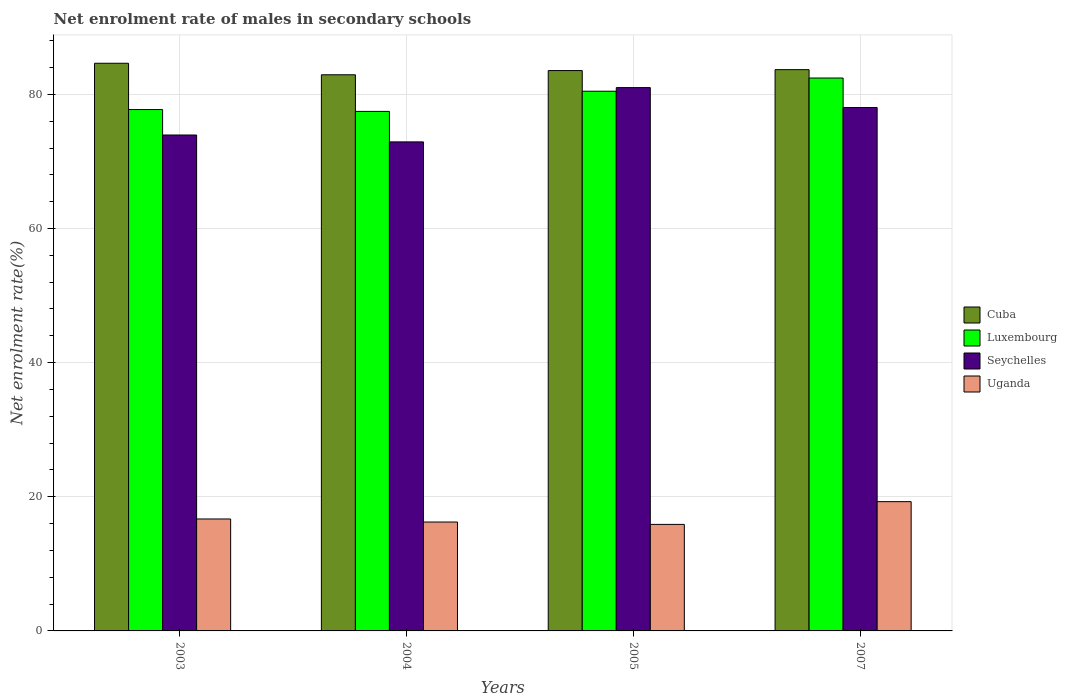How many different coloured bars are there?
Keep it short and to the point. 4. How many groups of bars are there?
Provide a succinct answer. 4. Are the number of bars on each tick of the X-axis equal?
Keep it short and to the point. Yes. What is the label of the 2nd group of bars from the left?
Your answer should be compact. 2004. What is the net enrolment rate of males in secondary schools in Luxembourg in 2005?
Your answer should be very brief. 80.46. Across all years, what is the maximum net enrolment rate of males in secondary schools in Cuba?
Your answer should be very brief. 84.63. Across all years, what is the minimum net enrolment rate of males in secondary schools in Seychelles?
Your answer should be compact. 72.91. What is the total net enrolment rate of males in secondary schools in Luxembourg in the graph?
Your answer should be compact. 318.09. What is the difference between the net enrolment rate of males in secondary schools in Cuba in 2004 and that in 2007?
Your answer should be very brief. -0.76. What is the difference between the net enrolment rate of males in secondary schools in Cuba in 2003 and the net enrolment rate of males in secondary schools in Uganda in 2004?
Keep it short and to the point. 68.4. What is the average net enrolment rate of males in secondary schools in Luxembourg per year?
Offer a very short reply. 79.52. In the year 2003, what is the difference between the net enrolment rate of males in secondary schools in Luxembourg and net enrolment rate of males in secondary schools in Seychelles?
Offer a terse response. 3.8. What is the ratio of the net enrolment rate of males in secondary schools in Seychelles in 2004 to that in 2007?
Your answer should be compact. 0.93. What is the difference between the highest and the second highest net enrolment rate of males in secondary schools in Seychelles?
Your answer should be very brief. 2.97. What is the difference between the highest and the lowest net enrolment rate of males in secondary schools in Cuba?
Ensure brevity in your answer.  1.72. What does the 4th bar from the left in 2004 represents?
Offer a terse response. Uganda. What does the 1st bar from the right in 2004 represents?
Provide a succinct answer. Uganda. Is it the case that in every year, the sum of the net enrolment rate of males in secondary schools in Uganda and net enrolment rate of males in secondary schools in Cuba is greater than the net enrolment rate of males in secondary schools in Luxembourg?
Give a very brief answer. Yes. Are all the bars in the graph horizontal?
Give a very brief answer. No. How many years are there in the graph?
Ensure brevity in your answer.  4. What is the difference between two consecutive major ticks on the Y-axis?
Give a very brief answer. 20. How many legend labels are there?
Provide a succinct answer. 4. How are the legend labels stacked?
Give a very brief answer. Vertical. What is the title of the graph?
Ensure brevity in your answer.  Net enrolment rate of males in secondary schools. What is the label or title of the Y-axis?
Make the answer very short. Net enrolment rate(%). What is the Net enrolment rate(%) in Cuba in 2003?
Ensure brevity in your answer.  84.63. What is the Net enrolment rate(%) of Luxembourg in 2003?
Your response must be concise. 77.73. What is the Net enrolment rate(%) in Seychelles in 2003?
Provide a short and direct response. 73.94. What is the Net enrolment rate(%) of Uganda in 2003?
Provide a succinct answer. 16.69. What is the Net enrolment rate(%) of Cuba in 2004?
Give a very brief answer. 82.92. What is the Net enrolment rate(%) in Luxembourg in 2004?
Ensure brevity in your answer.  77.46. What is the Net enrolment rate(%) of Seychelles in 2004?
Provide a succinct answer. 72.91. What is the Net enrolment rate(%) in Uganda in 2004?
Offer a terse response. 16.24. What is the Net enrolment rate(%) of Cuba in 2005?
Ensure brevity in your answer.  83.54. What is the Net enrolment rate(%) of Luxembourg in 2005?
Your answer should be very brief. 80.46. What is the Net enrolment rate(%) in Seychelles in 2005?
Provide a short and direct response. 81. What is the Net enrolment rate(%) of Uganda in 2005?
Offer a very short reply. 15.88. What is the Net enrolment rate(%) in Cuba in 2007?
Provide a succinct answer. 83.68. What is the Net enrolment rate(%) of Luxembourg in 2007?
Give a very brief answer. 82.43. What is the Net enrolment rate(%) of Seychelles in 2007?
Offer a terse response. 78.04. What is the Net enrolment rate(%) in Uganda in 2007?
Your answer should be compact. 19.27. Across all years, what is the maximum Net enrolment rate(%) of Cuba?
Offer a terse response. 84.63. Across all years, what is the maximum Net enrolment rate(%) in Luxembourg?
Your response must be concise. 82.43. Across all years, what is the maximum Net enrolment rate(%) of Seychelles?
Your answer should be very brief. 81. Across all years, what is the maximum Net enrolment rate(%) in Uganda?
Your response must be concise. 19.27. Across all years, what is the minimum Net enrolment rate(%) of Cuba?
Your answer should be very brief. 82.92. Across all years, what is the minimum Net enrolment rate(%) of Luxembourg?
Offer a terse response. 77.46. Across all years, what is the minimum Net enrolment rate(%) of Seychelles?
Give a very brief answer. 72.91. Across all years, what is the minimum Net enrolment rate(%) in Uganda?
Your response must be concise. 15.88. What is the total Net enrolment rate(%) in Cuba in the graph?
Make the answer very short. 334.78. What is the total Net enrolment rate(%) in Luxembourg in the graph?
Offer a terse response. 318.09. What is the total Net enrolment rate(%) of Seychelles in the graph?
Make the answer very short. 305.89. What is the total Net enrolment rate(%) of Uganda in the graph?
Make the answer very short. 68.08. What is the difference between the Net enrolment rate(%) in Cuba in 2003 and that in 2004?
Provide a succinct answer. 1.72. What is the difference between the Net enrolment rate(%) of Luxembourg in 2003 and that in 2004?
Offer a terse response. 0.28. What is the difference between the Net enrolment rate(%) of Seychelles in 2003 and that in 2004?
Give a very brief answer. 1.03. What is the difference between the Net enrolment rate(%) of Uganda in 2003 and that in 2004?
Make the answer very short. 0.45. What is the difference between the Net enrolment rate(%) of Cuba in 2003 and that in 2005?
Offer a terse response. 1.09. What is the difference between the Net enrolment rate(%) of Luxembourg in 2003 and that in 2005?
Your answer should be compact. -2.73. What is the difference between the Net enrolment rate(%) of Seychelles in 2003 and that in 2005?
Offer a very short reply. -7.07. What is the difference between the Net enrolment rate(%) of Uganda in 2003 and that in 2005?
Make the answer very short. 0.81. What is the difference between the Net enrolment rate(%) of Cuba in 2003 and that in 2007?
Ensure brevity in your answer.  0.95. What is the difference between the Net enrolment rate(%) in Luxembourg in 2003 and that in 2007?
Your response must be concise. -4.7. What is the difference between the Net enrolment rate(%) in Seychelles in 2003 and that in 2007?
Your answer should be compact. -4.1. What is the difference between the Net enrolment rate(%) in Uganda in 2003 and that in 2007?
Keep it short and to the point. -2.58. What is the difference between the Net enrolment rate(%) in Cuba in 2004 and that in 2005?
Provide a short and direct response. -0.63. What is the difference between the Net enrolment rate(%) in Luxembourg in 2004 and that in 2005?
Ensure brevity in your answer.  -3.01. What is the difference between the Net enrolment rate(%) in Seychelles in 2004 and that in 2005?
Keep it short and to the point. -8.09. What is the difference between the Net enrolment rate(%) in Uganda in 2004 and that in 2005?
Provide a short and direct response. 0.36. What is the difference between the Net enrolment rate(%) of Cuba in 2004 and that in 2007?
Ensure brevity in your answer.  -0.76. What is the difference between the Net enrolment rate(%) of Luxembourg in 2004 and that in 2007?
Ensure brevity in your answer.  -4.97. What is the difference between the Net enrolment rate(%) of Seychelles in 2004 and that in 2007?
Your answer should be compact. -5.13. What is the difference between the Net enrolment rate(%) in Uganda in 2004 and that in 2007?
Provide a succinct answer. -3.04. What is the difference between the Net enrolment rate(%) of Cuba in 2005 and that in 2007?
Provide a short and direct response. -0.14. What is the difference between the Net enrolment rate(%) of Luxembourg in 2005 and that in 2007?
Offer a terse response. -1.97. What is the difference between the Net enrolment rate(%) of Seychelles in 2005 and that in 2007?
Offer a terse response. 2.97. What is the difference between the Net enrolment rate(%) in Uganda in 2005 and that in 2007?
Offer a very short reply. -3.39. What is the difference between the Net enrolment rate(%) of Cuba in 2003 and the Net enrolment rate(%) of Luxembourg in 2004?
Your answer should be very brief. 7.18. What is the difference between the Net enrolment rate(%) of Cuba in 2003 and the Net enrolment rate(%) of Seychelles in 2004?
Your response must be concise. 11.72. What is the difference between the Net enrolment rate(%) in Cuba in 2003 and the Net enrolment rate(%) in Uganda in 2004?
Make the answer very short. 68.4. What is the difference between the Net enrolment rate(%) of Luxembourg in 2003 and the Net enrolment rate(%) of Seychelles in 2004?
Offer a terse response. 4.82. What is the difference between the Net enrolment rate(%) of Luxembourg in 2003 and the Net enrolment rate(%) of Uganda in 2004?
Your answer should be very brief. 61.5. What is the difference between the Net enrolment rate(%) in Seychelles in 2003 and the Net enrolment rate(%) in Uganda in 2004?
Make the answer very short. 57.7. What is the difference between the Net enrolment rate(%) in Cuba in 2003 and the Net enrolment rate(%) in Luxembourg in 2005?
Provide a short and direct response. 4.17. What is the difference between the Net enrolment rate(%) in Cuba in 2003 and the Net enrolment rate(%) in Seychelles in 2005?
Offer a very short reply. 3.63. What is the difference between the Net enrolment rate(%) in Cuba in 2003 and the Net enrolment rate(%) in Uganda in 2005?
Give a very brief answer. 68.75. What is the difference between the Net enrolment rate(%) of Luxembourg in 2003 and the Net enrolment rate(%) of Seychelles in 2005?
Provide a short and direct response. -3.27. What is the difference between the Net enrolment rate(%) in Luxembourg in 2003 and the Net enrolment rate(%) in Uganda in 2005?
Make the answer very short. 61.85. What is the difference between the Net enrolment rate(%) in Seychelles in 2003 and the Net enrolment rate(%) in Uganda in 2005?
Ensure brevity in your answer.  58.06. What is the difference between the Net enrolment rate(%) in Cuba in 2003 and the Net enrolment rate(%) in Luxembourg in 2007?
Give a very brief answer. 2.2. What is the difference between the Net enrolment rate(%) of Cuba in 2003 and the Net enrolment rate(%) of Seychelles in 2007?
Keep it short and to the point. 6.6. What is the difference between the Net enrolment rate(%) in Cuba in 2003 and the Net enrolment rate(%) in Uganda in 2007?
Provide a succinct answer. 65.36. What is the difference between the Net enrolment rate(%) of Luxembourg in 2003 and the Net enrolment rate(%) of Seychelles in 2007?
Make the answer very short. -0.3. What is the difference between the Net enrolment rate(%) of Luxembourg in 2003 and the Net enrolment rate(%) of Uganda in 2007?
Offer a terse response. 58.46. What is the difference between the Net enrolment rate(%) of Seychelles in 2003 and the Net enrolment rate(%) of Uganda in 2007?
Make the answer very short. 54.66. What is the difference between the Net enrolment rate(%) in Cuba in 2004 and the Net enrolment rate(%) in Luxembourg in 2005?
Your response must be concise. 2.45. What is the difference between the Net enrolment rate(%) of Cuba in 2004 and the Net enrolment rate(%) of Seychelles in 2005?
Ensure brevity in your answer.  1.91. What is the difference between the Net enrolment rate(%) of Cuba in 2004 and the Net enrolment rate(%) of Uganda in 2005?
Your answer should be very brief. 67.04. What is the difference between the Net enrolment rate(%) in Luxembourg in 2004 and the Net enrolment rate(%) in Seychelles in 2005?
Provide a short and direct response. -3.55. What is the difference between the Net enrolment rate(%) in Luxembourg in 2004 and the Net enrolment rate(%) in Uganda in 2005?
Offer a terse response. 61.58. What is the difference between the Net enrolment rate(%) in Seychelles in 2004 and the Net enrolment rate(%) in Uganda in 2005?
Give a very brief answer. 57.03. What is the difference between the Net enrolment rate(%) of Cuba in 2004 and the Net enrolment rate(%) of Luxembourg in 2007?
Provide a short and direct response. 0.49. What is the difference between the Net enrolment rate(%) of Cuba in 2004 and the Net enrolment rate(%) of Seychelles in 2007?
Provide a short and direct response. 4.88. What is the difference between the Net enrolment rate(%) of Cuba in 2004 and the Net enrolment rate(%) of Uganda in 2007?
Keep it short and to the point. 63.64. What is the difference between the Net enrolment rate(%) in Luxembourg in 2004 and the Net enrolment rate(%) in Seychelles in 2007?
Ensure brevity in your answer.  -0.58. What is the difference between the Net enrolment rate(%) in Luxembourg in 2004 and the Net enrolment rate(%) in Uganda in 2007?
Your answer should be very brief. 58.19. What is the difference between the Net enrolment rate(%) in Seychelles in 2004 and the Net enrolment rate(%) in Uganda in 2007?
Offer a very short reply. 53.64. What is the difference between the Net enrolment rate(%) of Cuba in 2005 and the Net enrolment rate(%) of Luxembourg in 2007?
Provide a short and direct response. 1.11. What is the difference between the Net enrolment rate(%) of Cuba in 2005 and the Net enrolment rate(%) of Seychelles in 2007?
Provide a short and direct response. 5.51. What is the difference between the Net enrolment rate(%) of Cuba in 2005 and the Net enrolment rate(%) of Uganda in 2007?
Provide a succinct answer. 64.27. What is the difference between the Net enrolment rate(%) of Luxembourg in 2005 and the Net enrolment rate(%) of Seychelles in 2007?
Provide a short and direct response. 2.43. What is the difference between the Net enrolment rate(%) in Luxembourg in 2005 and the Net enrolment rate(%) in Uganda in 2007?
Give a very brief answer. 61.19. What is the difference between the Net enrolment rate(%) of Seychelles in 2005 and the Net enrolment rate(%) of Uganda in 2007?
Ensure brevity in your answer.  61.73. What is the average Net enrolment rate(%) of Cuba per year?
Make the answer very short. 83.69. What is the average Net enrolment rate(%) in Luxembourg per year?
Your answer should be compact. 79.52. What is the average Net enrolment rate(%) of Seychelles per year?
Offer a very short reply. 76.47. What is the average Net enrolment rate(%) of Uganda per year?
Make the answer very short. 17.02. In the year 2003, what is the difference between the Net enrolment rate(%) of Cuba and Net enrolment rate(%) of Luxembourg?
Offer a terse response. 6.9. In the year 2003, what is the difference between the Net enrolment rate(%) of Cuba and Net enrolment rate(%) of Seychelles?
Ensure brevity in your answer.  10.7. In the year 2003, what is the difference between the Net enrolment rate(%) of Cuba and Net enrolment rate(%) of Uganda?
Ensure brevity in your answer.  67.94. In the year 2003, what is the difference between the Net enrolment rate(%) of Luxembourg and Net enrolment rate(%) of Seychelles?
Provide a short and direct response. 3.8. In the year 2003, what is the difference between the Net enrolment rate(%) of Luxembourg and Net enrolment rate(%) of Uganda?
Keep it short and to the point. 61.04. In the year 2003, what is the difference between the Net enrolment rate(%) in Seychelles and Net enrolment rate(%) in Uganda?
Your answer should be compact. 57.25. In the year 2004, what is the difference between the Net enrolment rate(%) of Cuba and Net enrolment rate(%) of Luxembourg?
Provide a succinct answer. 5.46. In the year 2004, what is the difference between the Net enrolment rate(%) of Cuba and Net enrolment rate(%) of Seychelles?
Your response must be concise. 10.01. In the year 2004, what is the difference between the Net enrolment rate(%) of Cuba and Net enrolment rate(%) of Uganda?
Keep it short and to the point. 66.68. In the year 2004, what is the difference between the Net enrolment rate(%) of Luxembourg and Net enrolment rate(%) of Seychelles?
Make the answer very short. 4.55. In the year 2004, what is the difference between the Net enrolment rate(%) in Luxembourg and Net enrolment rate(%) in Uganda?
Your answer should be very brief. 61.22. In the year 2004, what is the difference between the Net enrolment rate(%) in Seychelles and Net enrolment rate(%) in Uganda?
Give a very brief answer. 56.67. In the year 2005, what is the difference between the Net enrolment rate(%) in Cuba and Net enrolment rate(%) in Luxembourg?
Offer a terse response. 3.08. In the year 2005, what is the difference between the Net enrolment rate(%) in Cuba and Net enrolment rate(%) in Seychelles?
Make the answer very short. 2.54. In the year 2005, what is the difference between the Net enrolment rate(%) in Cuba and Net enrolment rate(%) in Uganda?
Your response must be concise. 67.66. In the year 2005, what is the difference between the Net enrolment rate(%) in Luxembourg and Net enrolment rate(%) in Seychelles?
Offer a terse response. -0.54. In the year 2005, what is the difference between the Net enrolment rate(%) of Luxembourg and Net enrolment rate(%) of Uganda?
Keep it short and to the point. 64.58. In the year 2005, what is the difference between the Net enrolment rate(%) of Seychelles and Net enrolment rate(%) of Uganda?
Keep it short and to the point. 65.12. In the year 2007, what is the difference between the Net enrolment rate(%) in Cuba and Net enrolment rate(%) in Luxembourg?
Provide a succinct answer. 1.25. In the year 2007, what is the difference between the Net enrolment rate(%) of Cuba and Net enrolment rate(%) of Seychelles?
Make the answer very short. 5.64. In the year 2007, what is the difference between the Net enrolment rate(%) of Cuba and Net enrolment rate(%) of Uganda?
Ensure brevity in your answer.  64.41. In the year 2007, what is the difference between the Net enrolment rate(%) in Luxembourg and Net enrolment rate(%) in Seychelles?
Your answer should be compact. 4.4. In the year 2007, what is the difference between the Net enrolment rate(%) of Luxembourg and Net enrolment rate(%) of Uganda?
Make the answer very short. 63.16. In the year 2007, what is the difference between the Net enrolment rate(%) in Seychelles and Net enrolment rate(%) in Uganda?
Your answer should be very brief. 58.76. What is the ratio of the Net enrolment rate(%) in Cuba in 2003 to that in 2004?
Your answer should be very brief. 1.02. What is the ratio of the Net enrolment rate(%) in Luxembourg in 2003 to that in 2004?
Make the answer very short. 1. What is the ratio of the Net enrolment rate(%) of Seychelles in 2003 to that in 2004?
Your answer should be very brief. 1.01. What is the ratio of the Net enrolment rate(%) of Uganda in 2003 to that in 2004?
Give a very brief answer. 1.03. What is the ratio of the Net enrolment rate(%) of Luxembourg in 2003 to that in 2005?
Your response must be concise. 0.97. What is the ratio of the Net enrolment rate(%) in Seychelles in 2003 to that in 2005?
Your answer should be very brief. 0.91. What is the ratio of the Net enrolment rate(%) in Uganda in 2003 to that in 2005?
Provide a short and direct response. 1.05. What is the ratio of the Net enrolment rate(%) of Cuba in 2003 to that in 2007?
Your answer should be compact. 1.01. What is the ratio of the Net enrolment rate(%) in Luxembourg in 2003 to that in 2007?
Ensure brevity in your answer.  0.94. What is the ratio of the Net enrolment rate(%) of Seychelles in 2003 to that in 2007?
Your answer should be very brief. 0.95. What is the ratio of the Net enrolment rate(%) of Uganda in 2003 to that in 2007?
Ensure brevity in your answer.  0.87. What is the ratio of the Net enrolment rate(%) of Luxembourg in 2004 to that in 2005?
Provide a succinct answer. 0.96. What is the ratio of the Net enrolment rate(%) of Seychelles in 2004 to that in 2005?
Make the answer very short. 0.9. What is the ratio of the Net enrolment rate(%) of Uganda in 2004 to that in 2005?
Offer a very short reply. 1.02. What is the ratio of the Net enrolment rate(%) in Cuba in 2004 to that in 2007?
Your response must be concise. 0.99. What is the ratio of the Net enrolment rate(%) of Luxembourg in 2004 to that in 2007?
Provide a succinct answer. 0.94. What is the ratio of the Net enrolment rate(%) in Seychelles in 2004 to that in 2007?
Give a very brief answer. 0.93. What is the ratio of the Net enrolment rate(%) of Uganda in 2004 to that in 2007?
Keep it short and to the point. 0.84. What is the ratio of the Net enrolment rate(%) in Cuba in 2005 to that in 2007?
Ensure brevity in your answer.  1. What is the ratio of the Net enrolment rate(%) of Luxembourg in 2005 to that in 2007?
Make the answer very short. 0.98. What is the ratio of the Net enrolment rate(%) in Seychelles in 2005 to that in 2007?
Offer a very short reply. 1.04. What is the ratio of the Net enrolment rate(%) in Uganda in 2005 to that in 2007?
Your answer should be very brief. 0.82. What is the difference between the highest and the second highest Net enrolment rate(%) of Cuba?
Provide a short and direct response. 0.95. What is the difference between the highest and the second highest Net enrolment rate(%) of Luxembourg?
Provide a succinct answer. 1.97. What is the difference between the highest and the second highest Net enrolment rate(%) in Seychelles?
Ensure brevity in your answer.  2.97. What is the difference between the highest and the second highest Net enrolment rate(%) in Uganda?
Your answer should be compact. 2.58. What is the difference between the highest and the lowest Net enrolment rate(%) of Cuba?
Provide a succinct answer. 1.72. What is the difference between the highest and the lowest Net enrolment rate(%) in Luxembourg?
Your answer should be compact. 4.97. What is the difference between the highest and the lowest Net enrolment rate(%) in Seychelles?
Your answer should be very brief. 8.09. What is the difference between the highest and the lowest Net enrolment rate(%) of Uganda?
Make the answer very short. 3.39. 